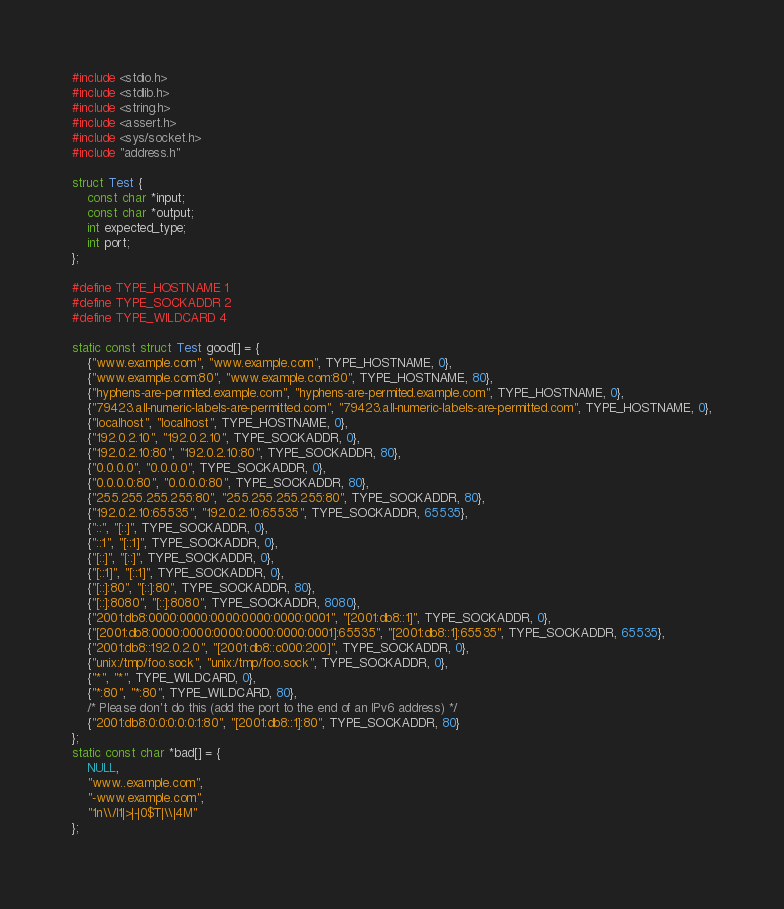<code> <loc_0><loc_0><loc_500><loc_500><_C_>#include <stdio.h>
#include <stdlib.h>
#include <string.h>
#include <assert.h>
#include <sys/socket.h>
#include "address.h"

struct Test {
    const char *input;
    const char *output;
    int expected_type;
    int port;
};

#define TYPE_HOSTNAME 1
#define TYPE_SOCKADDR 2
#define TYPE_WILDCARD 4

static const struct Test good[] = {
    {"www.example.com", "www.example.com", TYPE_HOSTNAME, 0},
    {"www.example.com:80", "www.example.com:80", TYPE_HOSTNAME, 80},
    {"hyphens-are-permited.example.com", "hyphens-are-permited.example.com", TYPE_HOSTNAME, 0},
    {"79423.all-numeric-labels-are-permitted.com", "79423.all-numeric-labels-are-permitted.com", TYPE_HOSTNAME, 0},
    {"localhost", "localhost", TYPE_HOSTNAME, 0},
    {"192.0.2.10", "192.0.2.10", TYPE_SOCKADDR, 0},
    {"192.0.2.10:80", "192.0.2.10:80", TYPE_SOCKADDR, 80},
    {"0.0.0.0", "0.0.0.0", TYPE_SOCKADDR, 0},
    {"0.0.0.0:80", "0.0.0.0:80", TYPE_SOCKADDR, 80},
    {"255.255.255.255:80", "255.255.255.255:80", TYPE_SOCKADDR, 80},
    {"192.0.2.10:65535", "192.0.2.10:65535", TYPE_SOCKADDR, 65535},
    {"::", "[::]", TYPE_SOCKADDR, 0},
    {"::1", "[::1]", TYPE_SOCKADDR, 0},
    {"[::]", "[::]", TYPE_SOCKADDR, 0},
    {"[::1]", "[::1]", TYPE_SOCKADDR, 0},
    {"[::]:80", "[::]:80", TYPE_SOCKADDR, 80},
    {"[::]:8080", "[::]:8080", TYPE_SOCKADDR, 8080},
    {"2001:db8:0000:0000:0000:0000:0000:0001", "[2001:db8::1]", TYPE_SOCKADDR, 0},
    {"[2001:db8:0000:0000:0000:0000:0000:0001]:65535", "[2001:db8::1]:65535", TYPE_SOCKADDR, 65535},
    {"2001:db8::192.0.2.0", "[2001:db8::c000:200]", TYPE_SOCKADDR, 0},
    {"unix:/tmp/foo.sock", "unix:/tmp/foo.sock", TYPE_SOCKADDR, 0},
    {"*", "*", TYPE_WILDCARD, 0},
    {"*:80", "*:80", TYPE_WILDCARD, 80},
    /* Please don't do this (add the port to the end of an IPv6 address) */
    {"2001:db8:0:0:0:0:0:1:80", "[2001:db8::1]:80", TYPE_SOCKADDR, 80}
};
static const char *bad[] = {
    NULL,
    "www..example.com",
    "-www.example.com",
    "1n\\/l1|>|-|0$T|\\|4M"
};
</code> 